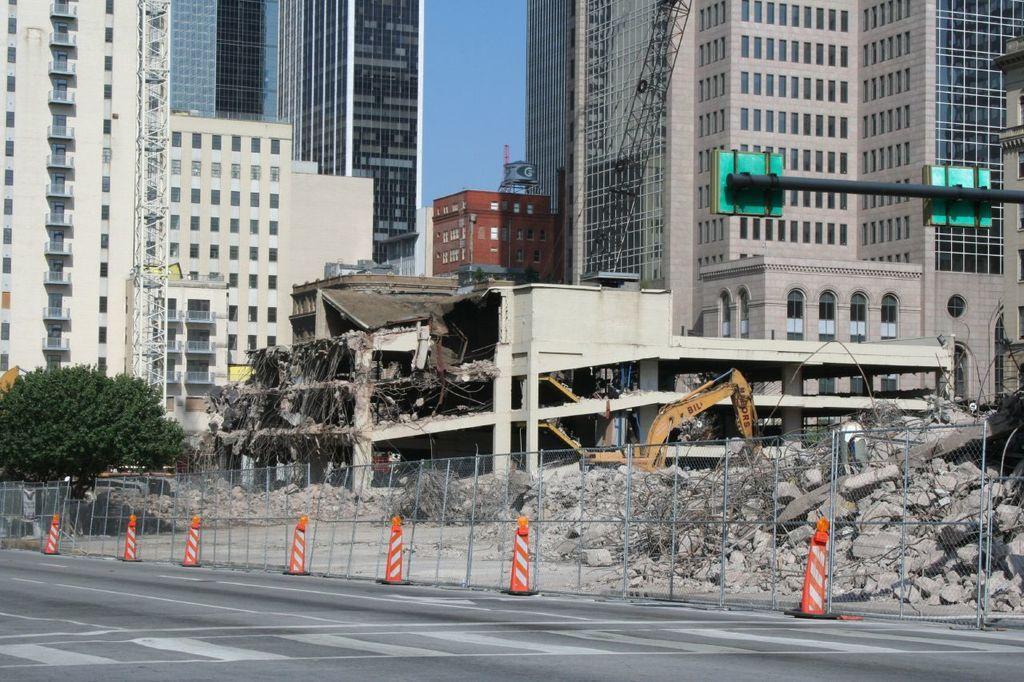Please provide a concise description of this image. In this image, we can see some buildings. There is a safety barrier and some divider cones beside the road. There is a tree on the left side of the image. There is a signal pole on the right side of the image. There is an excavator in the middle of the image. There is a sky at the top of the image. 